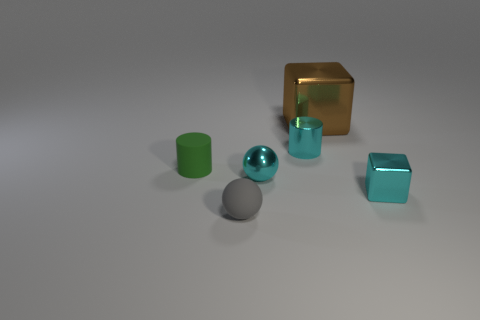Subtract all gray balls. How many balls are left? 1 Subtract all spheres. How many objects are left? 4 Add 3 tiny purple cylinders. How many objects exist? 9 Subtract all big purple matte cylinders. Subtract all small spheres. How many objects are left? 4 Add 4 large brown blocks. How many large brown blocks are left? 5 Add 6 tiny metal balls. How many tiny metal balls exist? 7 Subtract 0 blue cylinders. How many objects are left? 6 Subtract 1 spheres. How many spheres are left? 1 Subtract all green balls. Subtract all yellow cubes. How many balls are left? 2 Subtract all cyan cylinders. How many gray cubes are left? 0 